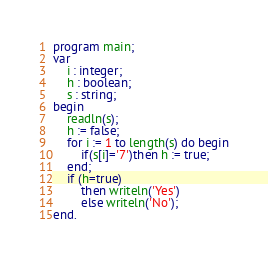Convert code to text. <code><loc_0><loc_0><loc_500><loc_500><_Pascal_>program main;
var 
	i : integer;
    h : boolean;
	s : string;
begin 
	readln(s);
    h := false;
    for i := 1 to length(s) do begin
    	if(s[i]='7')then h := true;
    end;
    if (h=true)
    	then writeln('Yes')
       	else writeln('No');
end.</code> 